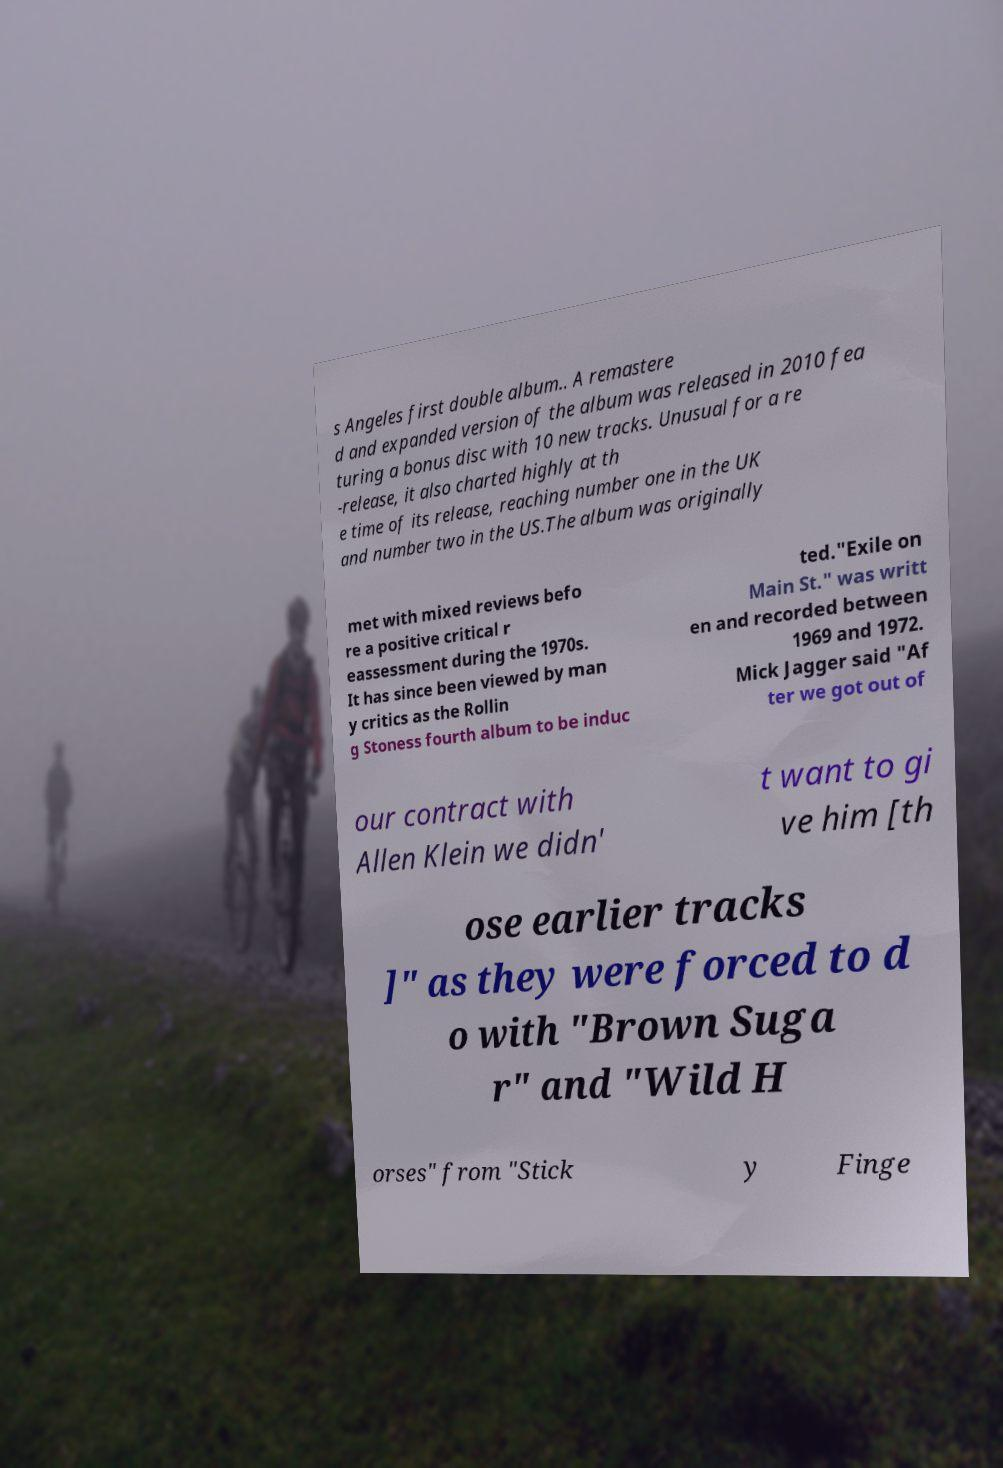There's text embedded in this image that I need extracted. Can you transcribe it verbatim? s Angeles first double album.. A remastere d and expanded version of the album was released in 2010 fea turing a bonus disc with 10 new tracks. Unusual for a re -release, it also charted highly at th e time of its release, reaching number one in the UK and number two in the US.The album was originally met with mixed reviews befo re a positive critical r eassessment during the 1970s. It has since been viewed by man y critics as the Rollin g Stoness fourth album to be induc ted."Exile on Main St." was writt en and recorded between 1969 and 1972. Mick Jagger said "Af ter we got out of our contract with Allen Klein we didn' t want to gi ve him [th ose earlier tracks ]" as they were forced to d o with "Brown Suga r" and "Wild H orses" from "Stick y Finge 